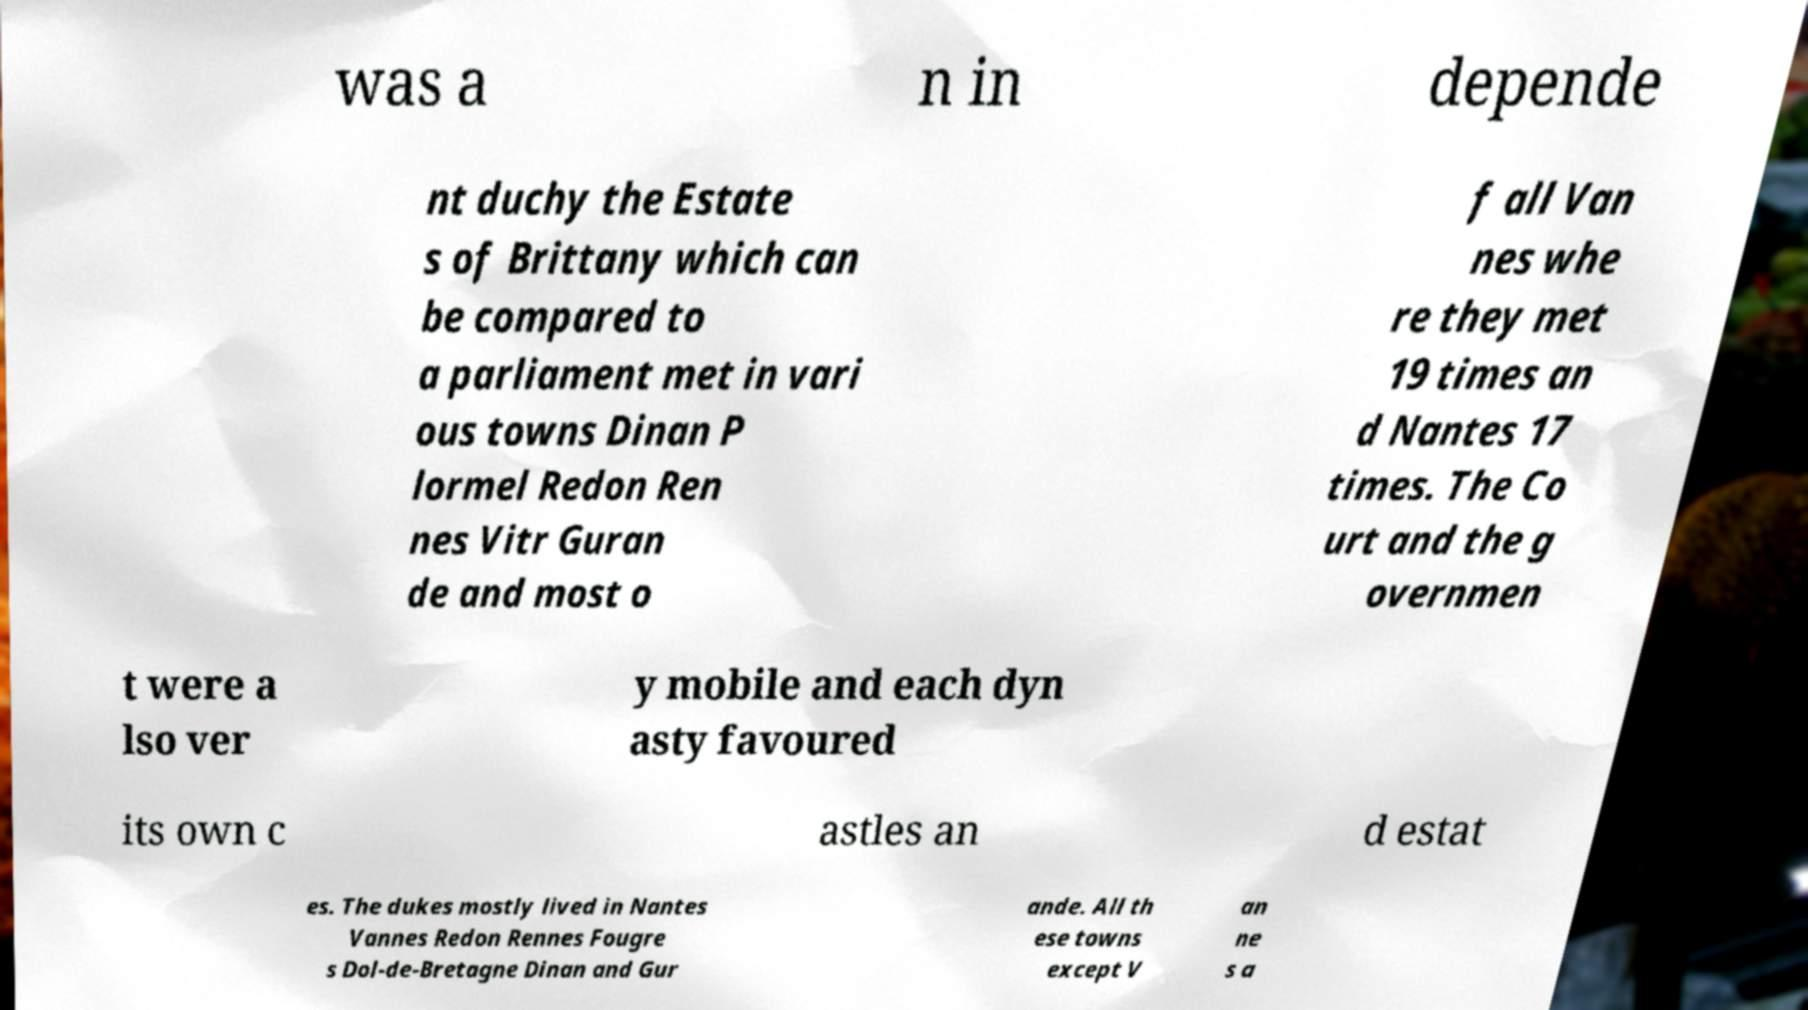Can you accurately transcribe the text from the provided image for me? was a n in depende nt duchy the Estate s of Brittany which can be compared to a parliament met in vari ous towns Dinan P lormel Redon Ren nes Vitr Guran de and most o f all Van nes whe re they met 19 times an d Nantes 17 times. The Co urt and the g overnmen t were a lso ver y mobile and each dyn asty favoured its own c astles an d estat es. The dukes mostly lived in Nantes Vannes Redon Rennes Fougre s Dol-de-Bretagne Dinan and Gur ande. All th ese towns except V an ne s a 